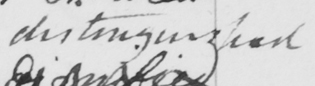Please provide the text content of this handwritten line. distinguished 